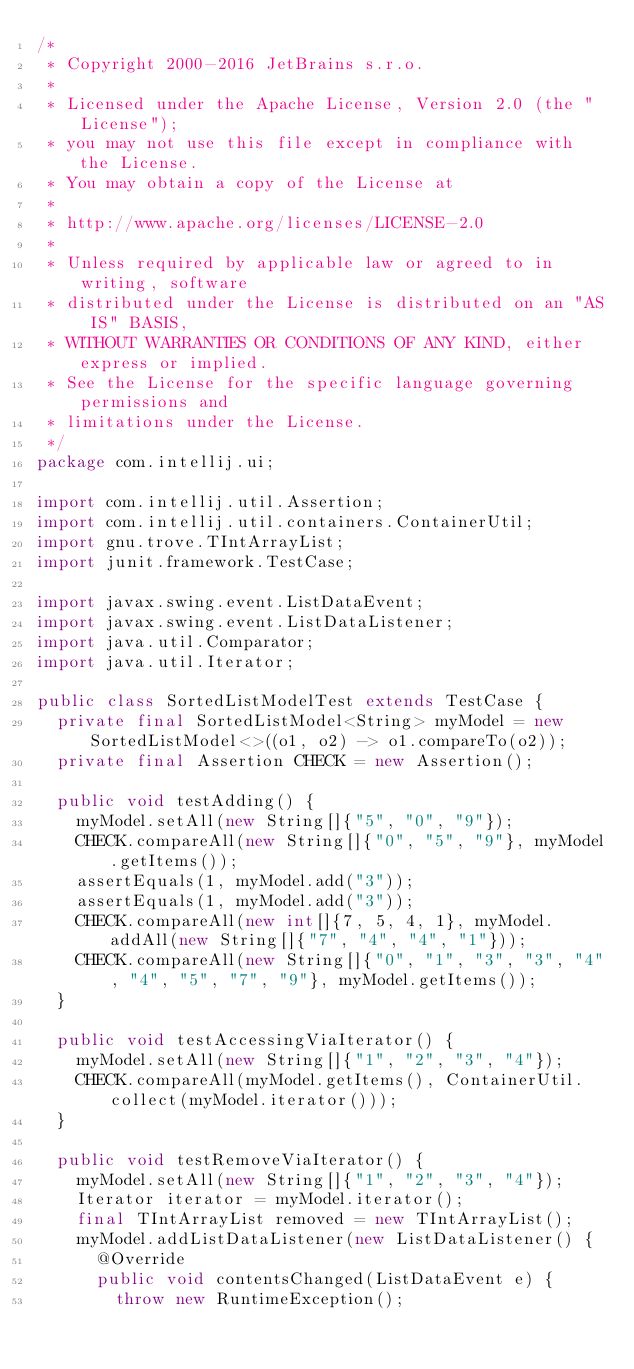<code> <loc_0><loc_0><loc_500><loc_500><_Java_>/*
 * Copyright 2000-2016 JetBrains s.r.o.
 *
 * Licensed under the Apache License, Version 2.0 (the "License");
 * you may not use this file except in compliance with the License.
 * You may obtain a copy of the License at
 *
 * http://www.apache.org/licenses/LICENSE-2.0
 *
 * Unless required by applicable law or agreed to in writing, software
 * distributed under the License is distributed on an "AS IS" BASIS,
 * WITHOUT WARRANTIES OR CONDITIONS OF ANY KIND, either express or implied.
 * See the License for the specific language governing permissions and
 * limitations under the License.
 */
package com.intellij.ui;

import com.intellij.util.Assertion;
import com.intellij.util.containers.ContainerUtil;
import gnu.trove.TIntArrayList;
import junit.framework.TestCase;

import javax.swing.event.ListDataEvent;
import javax.swing.event.ListDataListener;
import java.util.Comparator;
import java.util.Iterator;

public class SortedListModelTest extends TestCase {
  private final SortedListModel<String> myModel = new SortedListModel<>((o1, o2) -> o1.compareTo(o2));
  private final Assertion CHECK = new Assertion();

  public void testAdding() {
    myModel.setAll(new String[]{"5", "0", "9"});
    CHECK.compareAll(new String[]{"0", "5", "9"}, myModel.getItems());
    assertEquals(1, myModel.add("3"));
    assertEquals(1, myModel.add("3"));
    CHECK.compareAll(new int[]{7, 5, 4, 1}, myModel.addAll(new String[]{"7", "4", "4", "1"}));
    CHECK.compareAll(new String[]{"0", "1", "3", "3", "4", "4", "5", "7", "9"}, myModel.getItems());
  }

  public void testAccessingViaIterator() {
    myModel.setAll(new String[]{"1", "2", "3", "4"});
    CHECK.compareAll(myModel.getItems(), ContainerUtil.collect(myModel.iterator()));
  }

  public void testRemoveViaIterator() {
    myModel.setAll(new String[]{"1", "2", "3", "4"});
    Iterator iterator = myModel.iterator();
    final TIntArrayList removed = new TIntArrayList();
    myModel.addListDataListener(new ListDataListener() {
      @Override
      public void contentsChanged(ListDataEvent e) {
        throw new RuntimeException();</code> 